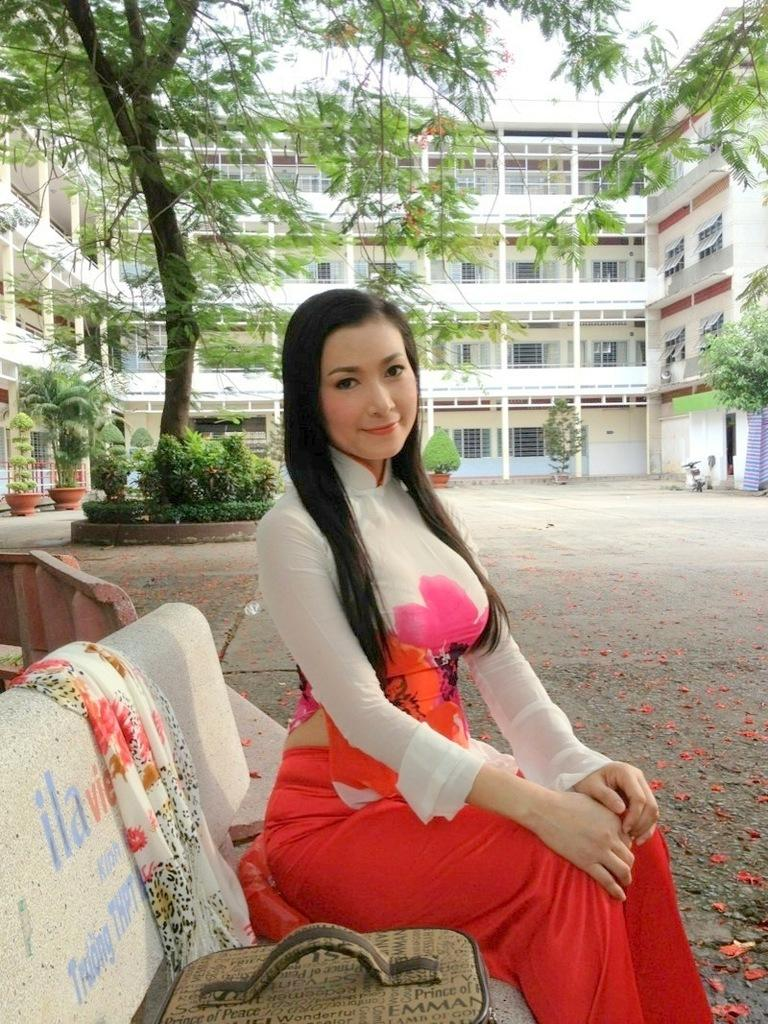What object can be seen in the image? There is a bag in the image. What material is present in the image? There is cloth in the image. What is the woman in the image doing? The woman is sitting on a bench in the image. What can be seen in the background of the image? The ground, plants, pots, trees, buildings with windows, and the sky are visible in the background of the image. How many boys are riding the trains in the image? There are no boys or trains present in the image. What type of hair is visible on the woman in the image? The image does not show the woman's hair, so it cannot be determined from the image. 